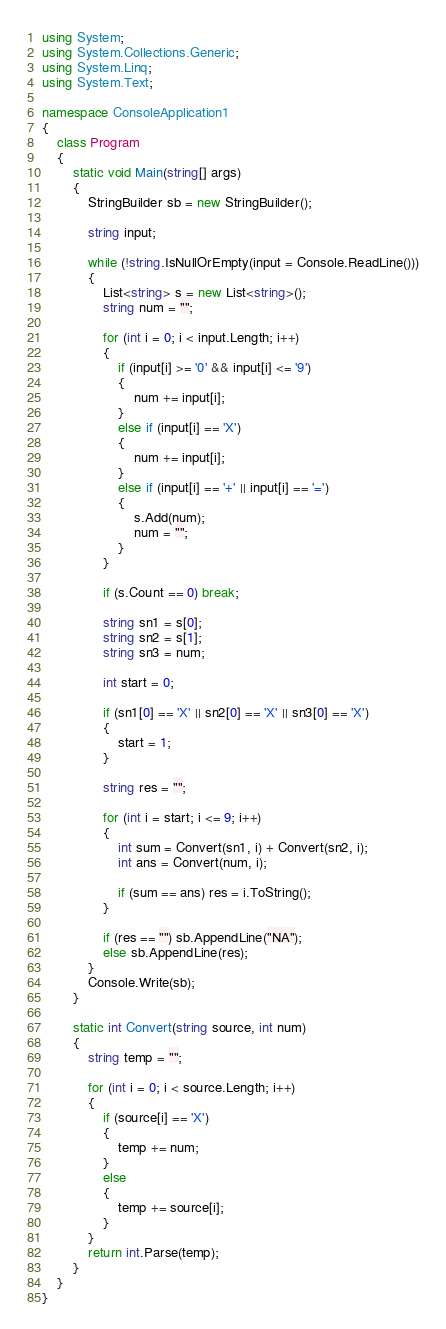Convert code to text. <code><loc_0><loc_0><loc_500><loc_500><_C#_>using System;
using System.Collections.Generic;
using System.Linq;
using System.Text;

namespace ConsoleApplication1
{
    class Program
    {
        static void Main(string[] args)
        {
            StringBuilder sb = new StringBuilder();

            string input;

            while (!string.IsNullOrEmpty(input = Console.ReadLine()))
            {
                List<string> s = new List<string>();
                string num = "";

                for (int i = 0; i < input.Length; i++)
                {
                    if (input[i] >= '0' && input[i] <= '9')
                    {
                        num += input[i];
                    }
                    else if (input[i] == 'X')
                    {
                        num += input[i];
                    }
                    else if (input[i] == '+' || input[i] == '=')
                    {
                        s.Add(num);
                        num = "";
                    }
                }

                if (s.Count == 0) break;

                string sn1 = s[0];
                string sn2 = s[1];
                string sn3 = num;

                int start = 0;

                if (sn1[0] == 'X' || sn2[0] == 'X' || sn3[0] == 'X')
                {
                    start = 1;
                }

                string res = "";

                for (int i = start; i <= 9; i++)
                {
                    int sum = Convert(sn1, i) + Convert(sn2, i);
                    int ans = Convert(num, i);

                    if (sum == ans) res = i.ToString();
                }

                if (res == "") sb.AppendLine("NA");
                else sb.AppendLine(res);
            }
            Console.Write(sb);
        }

        static int Convert(string source, int num)
        {
            string temp = "";

            for (int i = 0; i < source.Length; i++)
            {
                if (source[i] == 'X')
                {
                    temp += num;
                }
                else
                {
                    temp += source[i];
                }
            }
            return int.Parse(temp);
        }
    }
}</code> 